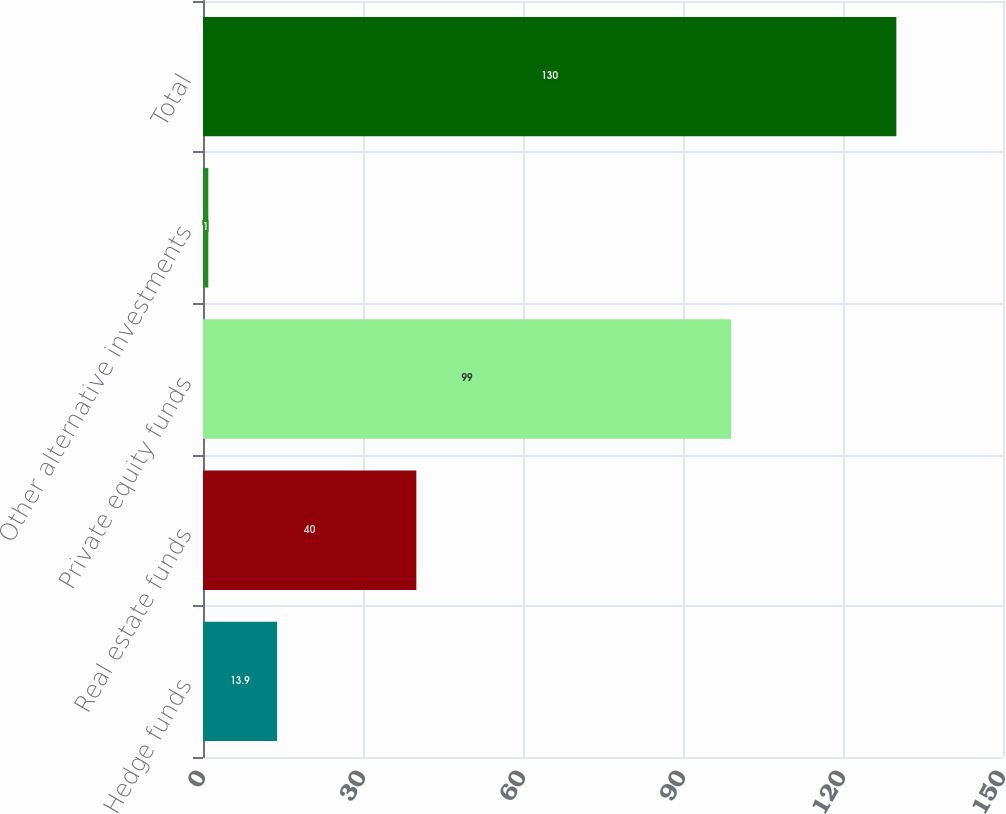Convert chart to OTSL. <chart><loc_0><loc_0><loc_500><loc_500><bar_chart><fcel>Hedge funds<fcel>Real estate funds<fcel>Private equity funds<fcel>Other alternative investments<fcel>Total<nl><fcel>13.9<fcel>40<fcel>99<fcel>1<fcel>130<nl></chart> 